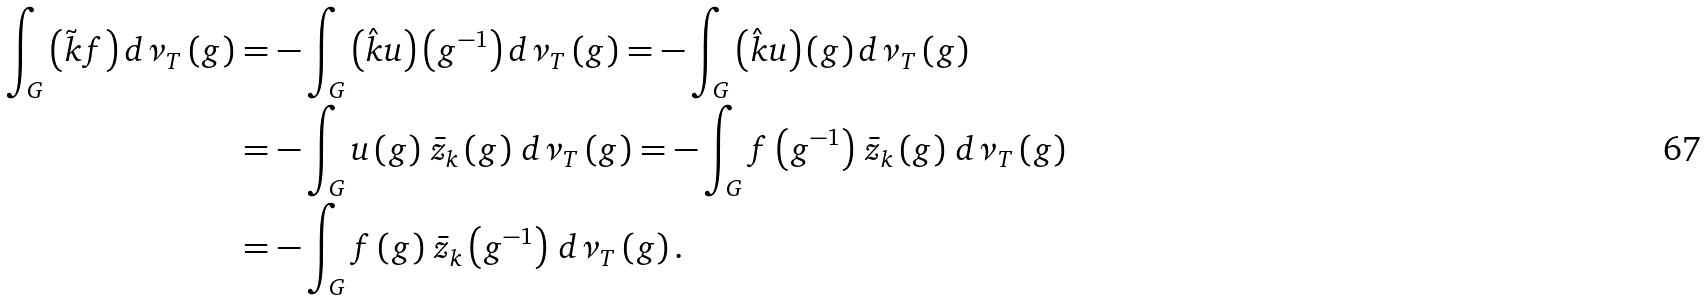<formula> <loc_0><loc_0><loc_500><loc_500>\int _ { G } \left ( \tilde { k } f \right ) d \nu _ { T } \left ( g \right ) & = - \int _ { G } \left ( \hat { k } u \right ) \left ( g ^ { - 1 } \right ) d \nu _ { T } \left ( g \right ) = - \int _ { G } \left ( \hat { k } u \right ) \left ( g \right ) d \nu _ { T } \left ( g \right ) \\ & = - \int _ { G } u \left ( g \right ) \, \bar { z } _ { k } \left ( g \right ) \, d \nu _ { T } \left ( g \right ) = - \int _ { G } f \left ( g ^ { - 1 } \right ) \, \bar { z } _ { k } \left ( g \right ) \, d \nu _ { T } \left ( g \right ) \\ & = - \int _ { G } f \left ( g \right ) \, \bar { z } _ { k } \left ( g ^ { - 1 } \right ) \, d \nu _ { T } \left ( g \right ) .</formula> 